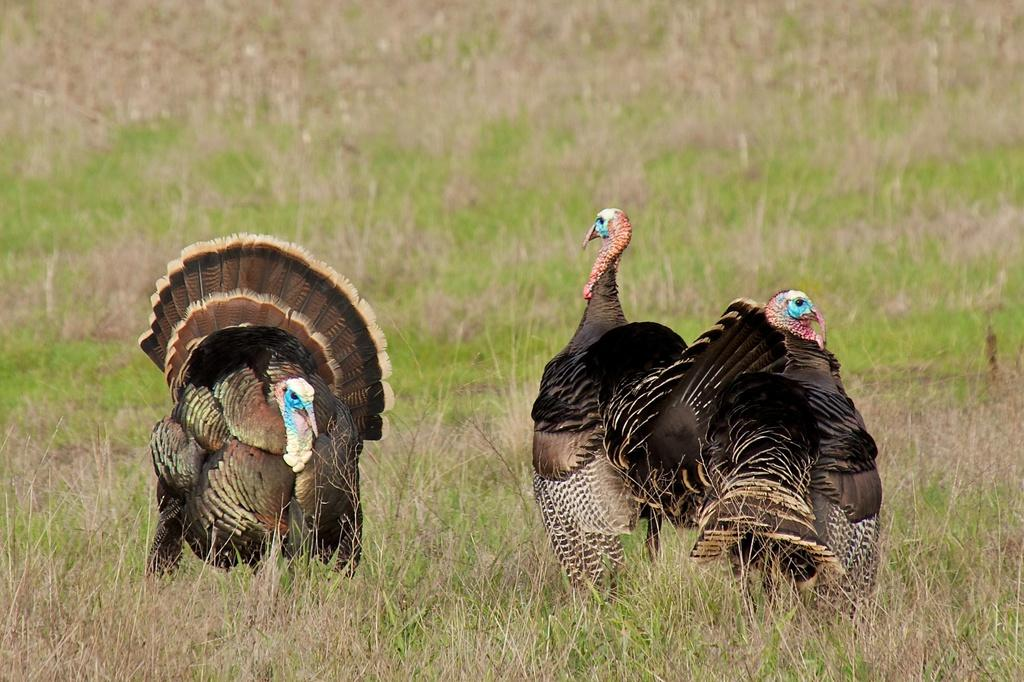What type of animals can be seen in the image? There are birds in the image. What colors are the birds in the image? The birds are in black, brown, and blue colors. Where are the birds located in the image? The birds are on the grass. Can you describe the background of the image? The background of the image is blurred. What type of company is represented by the birds in the image? There is no company represented by the birds in the image; they are simply birds in a natural setting. 